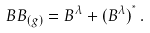<formula> <loc_0><loc_0><loc_500><loc_500>\ B B _ { ( g ) } = B ^ { \lambda } + ( B ^ { \lambda } ) ^ { ^ { * } } \, .</formula> 